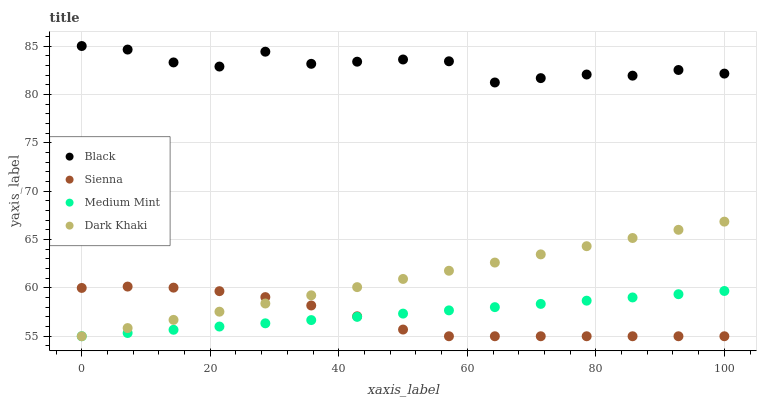Does Sienna have the minimum area under the curve?
Answer yes or no. Yes. Does Black have the maximum area under the curve?
Answer yes or no. Yes. Does Medium Mint have the minimum area under the curve?
Answer yes or no. No. Does Medium Mint have the maximum area under the curve?
Answer yes or no. No. Is Medium Mint the smoothest?
Answer yes or no. Yes. Is Black the roughest?
Answer yes or no. Yes. Is Black the smoothest?
Answer yes or no. No. Is Medium Mint the roughest?
Answer yes or no. No. Does Sienna have the lowest value?
Answer yes or no. Yes. Does Black have the lowest value?
Answer yes or no. No. Does Black have the highest value?
Answer yes or no. Yes. Does Medium Mint have the highest value?
Answer yes or no. No. Is Medium Mint less than Black?
Answer yes or no. Yes. Is Black greater than Dark Khaki?
Answer yes or no. Yes. Does Sienna intersect Medium Mint?
Answer yes or no. Yes. Is Sienna less than Medium Mint?
Answer yes or no. No. Is Sienna greater than Medium Mint?
Answer yes or no. No. Does Medium Mint intersect Black?
Answer yes or no. No. 